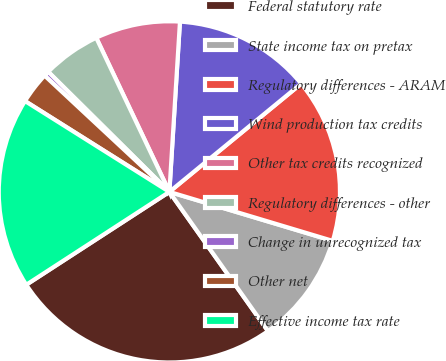Convert chart to OTSL. <chart><loc_0><loc_0><loc_500><loc_500><pie_chart><fcel>Federal statutory rate<fcel>State income tax on pretax<fcel>Regulatory differences - ARAM<fcel>Wind production tax credits<fcel>Other tax credits recognized<fcel>Regulatory differences - other<fcel>Change in unrecognized tax<fcel>Other net<fcel>Effective income tax rate<nl><fcel>25.65%<fcel>10.55%<fcel>15.58%<fcel>13.07%<fcel>8.04%<fcel>5.52%<fcel>0.49%<fcel>3.0%<fcel>18.1%<nl></chart> 